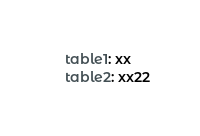Convert code to text. <code><loc_0><loc_0><loc_500><loc_500><_YAML_>    table1: xx
    table2: xx22</code> 